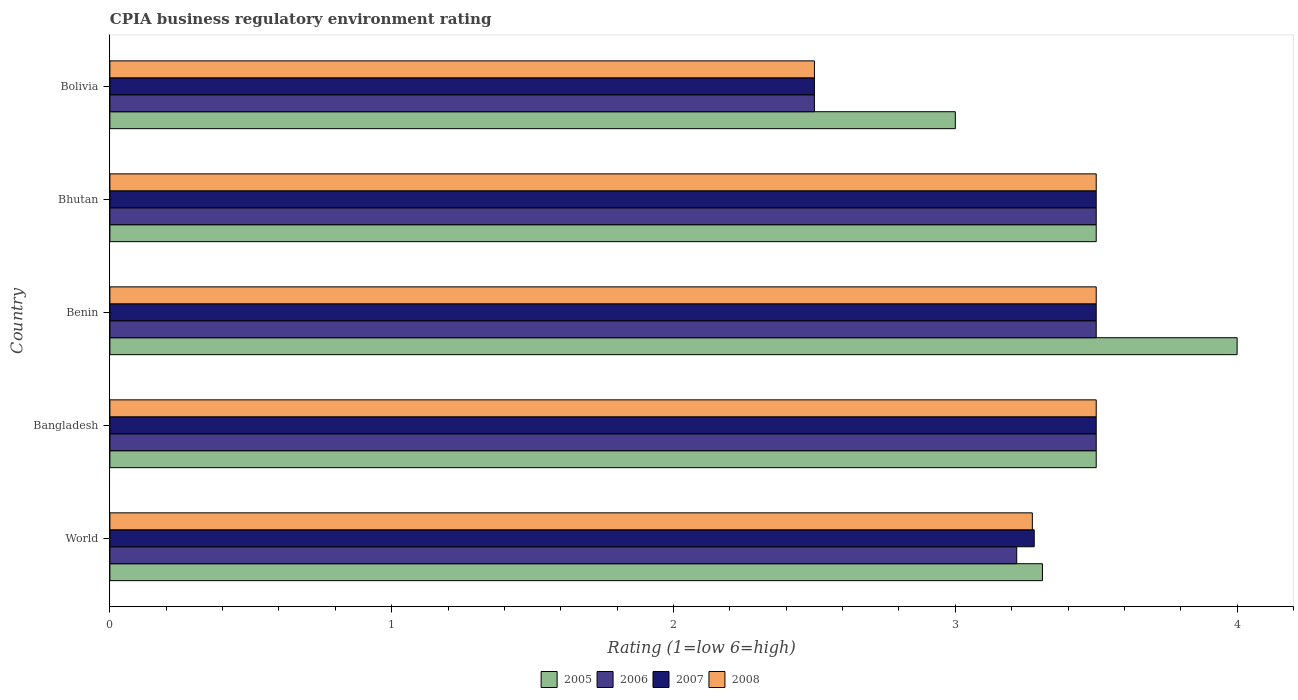How many different coloured bars are there?
Provide a short and direct response. 4. Are the number of bars on each tick of the Y-axis equal?
Offer a terse response. Yes. How many bars are there on the 4th tick from the top?
Offer a terse response. 4. What is the label of the 4th group of bars from the top?
Provide a succinct answer. Bangladesh. In how many cases, is the number of bars for a given country not equal to the number of legend labels?
Ensure brevity in your answer.  0. Across all countries, what is the maximum CPIA rating in 2008?
Ensure brevity in your answer.  3.5. Across all countries, what is the minimum CPIA rating in 2007?
Give a very brief answer. 2.5. What is the total CPIA rating in 2008 in the graph?
Keep it short and to the point. 16.27. What is the difference between the CPIA rating in 2006 in Bolivia and that in World?
Offer a terse response. -0.72. What is the difference between the CPIA rating in 2005 in Bolivia and the CPIA rating in 2007 in Bhutan?
Provide a succinct answer. -0.5. What is the average CPIA rating in 2007 per country?
Your answer should be very brief. 3.26. What is the ratio of the CPIA rating in 2007 in Bolivia to that in World?
Provide a succinct answer. 0.76. Is the CPIA rating in 2005 in Benin less than that in World?
Your response must be concise. No. Is the difference between the CPIA rating in 2005 in Bangladesh and Bolivia greater than the difference between the CPIA rating in 2008 in Bangladesh and Bolivia?
Keep it short and to the point. No. What is the difference between the highest and the second highest CPIA rating in 2005?
Ensure brevity in your answer.  0.5. Is it the case that in every country, the sum of the CPIA rating in 2005 and CPIA rating in 2007 is greater than the sum of CPIA rating in 2006 and CPIA rating in 2008?
Ensure brevity in your answer.  No. What does the 4th bar from the top in Bangladesh represents?
Provide a short and direct response. 2005. What does the 1st bar from the bottom in Benin represents?
Give a very brief answer. 2005. Is it the case that in every country, the sum of the CPIA rating in 2007 and CPIA rating in 2008 is greater than the CPIA rating in 2005?
Provide a short and direct response. Yes. Are all the bars in the graph horizontal?
Give a very brief answer. Yes. How many countries are there in the graph?
Offer a terse response. 5. What is the difference between two consecutive major ticks on the X-axis?
Your answer should be compact. 1. Does the graph contain grids?
Your answer should be very brief. No. How many legend labels are there?
Your answer should be very brief. 4. How are the legend labels stacked?
Offer a terse response. Horizontal. What is the title of the graph?
Provide a short and direct response. CPIA business regulatory environment rating. Does "1987" appear as one of the legend labels in the graph?
Offer a terse response. No. What is the label or title of the Y-axis?
Your answer should be compact. Country. What is the Rating (1=low 6=high) of 2005 in World?
Your answer should be compact. 3.31. What is the Rating (1=low 6=high) of 2006 in World?
Make the answer very short. 3.22. What is the Rating (1=low 6=high) of 2007 in World?
Ensure brevity in your answer.  3.28. What is the Rating (1=low 6=high) in 2008 in World?
Your response must be concise. 3.27. What is the Rating (1=low 6=high) in 2005 in Bangladesh?
Your response must be concise. 3.5. What is the Rating (1=low 6=high) of 2006 in Bangladesh?
Provide a short and direct response. 3.5. What is the Rating (1=low 6=high) of 2007 in Bangladesh?
Give a very brief answer. 3.5. What is the Rating (1=low 6=high) of 2008 in Bangladesh?
Provide a short and direct response. 3.5. What is the Rating (1=low 6=high) of 2005 in Benin?
Give a very brief answer. 4. What is the Rating (1=low 6=high) of 2008 in Bhutan?
Give a very brief answer. 3.5. What is the Rating (1=low 6=high) in 2005 in Bolivia?
Provide a short and direct response. 3. What is the Rating (1=low 6=high) of 2007 in Bolivia?
Your response must be concise. 2.5. What is the Rating (1=low 6=high) of 2008 in Bolivia?
Keep it short and to the point. 2.5. Across all countries, what is the maximum Rating (1=low 6=high) in 2008?
Provide a succinct answer. 3.5. Across all countries, what is the minimum Rating (1=low 6=high) in 2006?
Keep it short and to the point. 2.5. Across all countries, what is the minimum Rating (1=low 6=high) of 2008?
Offer a very short reply. 2.5. What is the total Rating (1=low 6=high) of 2005 in the graph?
Offer a very short reply. 17.31. What is the total Rating (1=low 6=high) of 2006 in the graph?
Your answer should be compact. 16.22. What is the total Rating (1=low 6=high) in 2007 in the graph?
Provide a succinct answer. 16.28. What is the total Rating (1=low 6=high) of 2008 in the graph?
Provide a short and direct response. 16.27. What is the difference between the Rating (1=low 6=high) of 2005 in World and that in Bangladesh?
Offer a terse response. -0.19. What is the difference between the Rating (1=low 6=high) in 2006 in World and that in Bangladesh?
Keep it short and to the point. -0.28. What is the difference between the Rating (1=low 6=high) of 2007 in World and that in Bangladesh?
Give a very brief answer. -0.22. What is the difference between the Rating (1=low 6=high) of 2008 in World and that in Bangladesh?
Provide a short and direct response. -0.23. What is the difference between the Rating (1=low 6=high) in 2005 in World and that in Benin?
Your answer should be very brief. -0.69. What is the difference between the Rating (1=low 6=high) in 2006 in World and that in Benin?
Your answer should be compact. -0.28. What is the difference between the Rating (1=low 6=high) of 2007 in World and that in Benin?
Provide a succinct answer. -0.22. What is the difference between the Rating (1=low 6=high) of 2008 in World and that in Benin?
Your answer should be compact. -0.23. What is the difference between the Rating (1=low 6=high) in 2005 in World and that in Bhutan?
Offer a terse response. -0.19. What is the difference between the Rating (1=low 6=high) in 2006 in World and that in Bhutan?
Offer a terse response. -0.28. What is the difference between the Rating (1=low 6=high) in 2007 in World and that in Bhutan?
Ensure brevity in your answer.  -0.22. What is the difference between the Rating (1=low 6=high) in 2008 in World and that in Bhutan?
Your answer should be compact. -0.23. What is the difference between the Rating (1=low 6=high) in 2005 in World and that in Bolivia?
Give a very brief answer. 0.31. What is the difference between the Rating (1=low 6=high) of 2006 in World and that in Bolivia?
Offer a very short reply. 0.72. What is the difference between the Rating (1=low 6=high) of 2007 in World and that in Bolivia?
Your answer should be compact. 0.78. What is the difference between the Rating (1=low 6=high) in 2008 in World and that in Bolivia?
Give a very brief answer. 0.77. What is the difference between the Rating (1=low 6=high) in 2008 in Bangladesh and that in Benin?
Offer a terse response. 0. What is the difference between the Rating (1=low 6=high) in 2007 in Bangladesh and that in Bhutan?
Your response must be concise. 0. What is the difference between the Rating (1=low 6=high) of 2008 in Bangladesh and that in Bhutan?
Offer a very short reply. 0. What is the difference between the Rating (1=low 6=high) in 2007 in Benin and that in Bhutan?
Make the answer very short. 0. What is the difference between the Rating (1=low 6=high) in 2006 in Benin and that in Bolivia?
Keep it short and to the point. 1. What is the difference between the Rating (1=low 6=high) of 2006 in Bhutan and that in Bolivia?
Offer a terse response. 1. What is the difference between the Rating (1=low 6=high) in 2007 in Bhutan and that in Bolivia?
Your answer should be very brief. 1. What is the difference between the Rating (1=low 6=high) in 2005 in World and the Rating (1=low 6=high) in 2006 in Bangladesh?
Your answer should be very brief. -0.19. What is the difference between the Rating (1=low 6=high) in 2005 in World and the Rating (1=low 6=high) in 2007 in Bangladesh?
Your answer should be compact. -0.19. What is the difference between the Rating (1=low 6=high) in 2005 in World and the Rating (1=low 6=high) in 2008 in Bangladesh?
Provide a short and direct response. -0.19. What is the difference between the Rating (1=low 6=high) in 2006 in World and the Rating (1=low 6=high) in 2007 in Bangladesh?
Your response must be concise. -0.28. What is the difference between the Rating (1=low 6=high) of 2006 in World and the Rating (1=low 6=high) of 2008 in Bangladesh?
Your answer should be compact. -0.28. What is the difference between the Rating (1=low 6=high) in 2007 in World and the Rating (1=low 6=high) in 2008 in Bangladesh?
Provide a succinct answer. -0.22. What is the difference between the Rating (1=low 6=high) in 2005 in World and the Rating (1=low 6=high) in 2006 in Benin?
Keep it short and to the point. -0.19. What is the difference between the Rating (1=low 6=high) of 2005 in World and the Rating (1=low 6=high) of 2007 in Benin?
Your answer should be very brief. -0.19. What is the difference between the Rating (1=low 6=high) in 2005 in World and the Rating (1=low 6=high) in 2008 in Benin?
Ensure brevity in your answer.  -0.19. What is the difference between the Rating (1=low 6=high) in 2006 in World and the Rating (1=low 6=high) in 2007 in Benin?
Your answer should be very brief. -0.28. What is the difference between the Rating (1=low 6=high) in 2006 in World and the Rating (1=low 6=high) in 2008 in Benin?
Your answer should be compact. -0.28. What is the difference between the Rating (1=low 6=high) of 2007 in World and the Rating (1=low 6=high) of 2008 in Benin?
Provide a succinct answer. -0.22. What is the difference between the Rating (1=low 6=high) of 2005 in World and the Rating (1=low 6=high) of 2006 in Bhutan?
Make the answer very short. -0.19. What is the difference between the Rating (1=low 6=high) of 2005 in World and the Rating (1=low 6=high) of 2007 in Bhutan?
Keep it short and to the point. -0.19. What is the difference between the Rating (1=low 6=high) of 2005 in World and the Rating (1=low 6=high) of 2008 in Bhutan?
Give a very brief answer. -0.19. What is the difference between the Rating (1=low 6=high) in 2006 in World and the Rating (1=low 6=high) in 2007 in Bhutan?
Provide a succinct answer. -0.28. What is the difference between the Rating (1=low 6=high) of 2006 in World and the Rating (1=low 6=high) of 2008 in Bhutan?
Ensure brevity in your answer.  -0.28. What is the difference between the Rating (1=low 6=high) of 2007 in World and the Rating (1=low 6=high) of 2008 in Bhutan?
Keep it short and to the point. -0.22. What is the difference between the Rating (1=low 6=high) in 2005 in World and the Rating (1=low 6=high) in 2006 in Bolivia?
Provide a succinct answer. 0.81. What is the difference between the Rating (1=low 6=high) of 2005 in World and the Rating (1=low 6=high) of 2007 in Bolivia?
Your answer should be very brief. 0.81. What is the difference between the Rating (1=low 6=high) of 2005 in World and the Rating (1=low 6=high) of 2008 in Bolivia?
Your answer should be very brief. 0.81. What is the difference between the Rating (1=low 6=high) in 2006 in World and the Rating (1=low 6=high) in 2007 in Bolivia?
Your response must be concise. 0.72. What is the difference between the Rating (1=low 6=high) in 2006 in World and the Rating (1=low 6=high) in 2008 in Bolivia?
Ensure brevity in your answer.  0.72. What is the difference between the Rating (1=low 6=high) of 2007 in World and the Rating (1=low 6=high) of 2008 in Bolivia?
Provide a succinct answer. 0.78. What is the difference between the Rating (1=low 6=high) of 2005 in Bangladesh and the Rating (1=low 6=high) of 2006 in Benin?
Provide a short and direct response. 0. What is the difference between the Rating (1=low 6=high) in 2005 in Bangladesh and the Rating (1=low 6=high) in 2007 in Benin?
Offer a terse response. 0. What is the difference between the Rating (1=low 6=high) in 2005 in Bangladesh and the Rating (1=low 6=high) in 2008 in Benin?
Offer a very short reply. 0. What is the difference between the Rating (1=low 6=high) of 2006 in Bangladesh and the Rating (1=low 6=high) of 2007 in Benin?
Give a very brief answer. 0. What is the difference between the Rating (1=low 6=high) in 2006 in Bangladesh and the Rating (1=low 6=high) in 2008 in Benin?
Your answer should be compact. 0. What is the difference between the Rating (1=low 6=high) of 2005 in Bangladesh and the Rating (1=low 6=high) of 2007 in Bhutan?
Offer a terse response. 0. What is the difference between the Rating (1=low 6=high) in 2005 in Bangladesh and the Rating (1=low 6=high) in 2008 in Bhutan?
Your response must be concise. 0. What is the difference between the Rating (1=low 6=high) in 2006 in Bangladesh and the Rating (1=low 6=high) in 2007 in Bhutan?
Make the answer very short. 0. What is the difference between the Rating (1=low 6=high) in 2006 in Bangladesh and the Rating (1=low 6=high) in 2008 in Bhutan?
Ensure brevity in your answer.  0. What is the difference between the Rating (1=low 6=high) of 2005 in Bangladesh and the Rating (1=low 6=high) of 2006 in Bolivia?
Provide a short and direct response. 1. What is the difference between the Rating (1=low 6=high) of 2007 in Bangladesh and the Rating (1=low 6=high) of 2008 in Bolivia?
Give a very brief answer. 1. What is the difference between the Rating (1=low 6=high) of 2005 in Benin and the Rating (1=low 6=high) of 2006 in Bhutan?
Make the answer very short. 0.5. What is the difference between the Rating (1=low 6=high) in 2005 in Benin and the Rating (1=low 6=high) in 2008 in Bhutan?
Your response must be concise. 0.5. What is the difference between the Rating (1=low 6=high) in 2006 in Benin and the Rating (1=low 6=high) in 2007 in Bhutan?
Give a very brief answer. 0. What is the difference between the Rating (1=low 6=high) in 2006 in Benin and the Rating (1=low 6=high) in 2008 in Bhutan?
Your answer should be very brief. 0. What is the difference between the Rating (1=low 6=high) of 2007 in Benin and the Rating (1=low 6=high) of 2008 in Bhutan?
Provide a short and direct response. 0. What is the difference between the Rating (1=low 6=high) in 2005 in Benin and the Rating (1=low 6=high) in 2007 in Bolivia?
Your response must be concise. 1.5. What is the difference between the Rating (1=low 6=high) in 2006 in Benin and the Rating (1=low 6=high) in 2007 in Bolivia?
Ensure brevity in your answer.  1. What is the difference between the Rating (1=low 6=high) in 2005 in Bhutan and the Rating (1=low 6=high) in 2006 in Bolivia?
Offer a terse response. 1. What is the difference between the Rating (1=low 6=high) in 2005 in Bhutan and the Rating (1=low 6=high) in 2007 in Bolivia?
Offer a very short reply. 1. What is the difference between the Rating (1=low 6=high) of 2006 in Bhutan and the Rating (1=low 6=high) of 2007 in Bolivia?
Offer a very short reply. 1. What is the difference between the Rating (1=low 6=high) in 2006 in Bhutan and the Rating (1=low 6=high) in 2008 in Bolivia?
Offer a terse response. 1. What is the average Rating (1=low 6=high) in 2005 per country?
Keep it short and to the point. 3.46. What is the average Rating (1=low 6=high) in 2006 per country?
Your answer should be very brief. 3.24. What is the average Rating (1=low 6=high) in 2007 per country?
Offer a terse response. 3.26. What is the average Rating (1=low 6=high) of 2008 per country?
Ensure brevity in your answer.  3.25. What is the difference between the Rating (1=low 6=high) in 2005 and Rating (1=low 6=high) in 2006 in World?
Give a very brief answer. 0.09. What is the difference between the Rating (1=low 6=high) in 2005 and Rating (1=low 6=high) in 2007 in World?
Your answer should be very brief. 0.03. What is the difference between the Rating (1=low 6=high) in 2005 and Rating (1=low 6=high) in 2008 in World?
Your answer should be compact. 0.04. What is the difference between the Rating (1=low 6=high) of 2006 and Rating (1=low 6=high) of 2007 in World?
Offer a terse response. -0.06. What is the difference between the Rating (1=low 6=high) in 2006 and Rating (1=low 6=high) in 2008 in World?
Give a very brief answer. -0.06. What is the difference between the Rating (1=low 6=high) of 2007 and Rating (1=low 6=high) of 2008 in World?
Your answer should be compact. 0.01. What is the difference between the Rating (1=low 6=high) in 2005 and Rating (1=low 6=high) in 2007 in Bangladesh?
Make the answer very short. 0. What is the difference between the Rating (1=low 6=high) of 2006 and Rating (1=low 6=high) of 2008 in Bangladesh?
Your answer should be very brief. 0. What is the difference between the Rating (1=low 6=high) in 2005 and Rating (1=low 6=high) in 2007 in Benin?
Provide a succinct answer. 0.5. What is the difference between the Rating (1=low 6=high) in 2005 and Rating (1=low 6=high) in 2008 in Benin?
Your response must be concise. 0.5. What is the difference between the Rating (1=low 6=high) of 2006 and Rating (1=low 6=high) of 2007 in Benin?
Provide a succinct answer. 0. What is the difference between the Rating (1=low 6=high) of 2006 and Rating (1=low 6=high) of 2008 in Benin?
Give a very brief answer. 0. What is the difference between the Rating (1=low 6=high) in 2007 and Rating (1=low 6=high) in 2008 in Benin?
Your answer should be compact. 0. What is the difference between the Rating (1=low 6=high) of 2006 and Rating (1=low 6=high) of 2007 in Bhutan?
Give a very brief answer. 0. What is the difference between the Rating (1=low 6=high) in 2006 and Rating (1=low 6=high) in 2008 in Bhutan?
Offer a terse response. 0. What is the difference between the Rating (1=low 6=high) of 2007 and Rating (1=low 6=high) of 2008 in Bhutan?
Your response must be concise. 0. What is the difference between the Rating (1=low 6=high) of 2005 and Rating (1=low 6=high) of 2006 in Bolivia?
Make the answer very short. 0.5. What is the difference between the Rating (1=low 6=high) in 2006 and Rating (1=low 6=high) in 2007 in Bolivia?
Provide a succinct answer. 0. What is the difference between the Rating (1=low 6=high) of 2007 and Rating (1=low 6=high) of 2008 in Bolivia?
Offer a terse response. 0. What is the ratio of the Rating (1=low 6=high) in 2005 in World to that in Bangladesh?
Your response must be concise. 0.95. What is the ratio of the Rating (1=low 6=high) of 2006 in World to that in Bangladesh?
Keep it short and to the point. 0.92. What is the ratio of the Rating (1=low 6=high) of 2007 in World to that in Bangladesh?
Provide a short and direct response. 0.94. What is the ratio of the Rating (1=low 6=high) of 2008 in World to that in Bangladesh?
Your response must be concise. 0.94. What is the ratio of the Rating (1=low 6=high) of 2005 in World to that in Benin?
Make the answer very short. 0.83. What is the ratio of the Rating (1=low 6=high) in 2006 in World to that in Benin?
Provide a short and direct response. 0.92. What is the ratio of the Rating (1=low 6=high) in 2007 in World to that in Benin?
Ensure brevity in your answer.  0.94. What is the ratio of the Rating (1=low 6=high) of 2008 in World to that in Benin?
Your answer should be compact. 0.94. What is the ratio of the Rating (1=low 6=high) of 2005 in World to that in Bhutan?
Ensure brevity in your answer.  0.95. What is the ratio of the Rating (1=low 6=high) in 2006 in World to that in Bhutan?
Give a very brief answer. 0.92. What is the ratio of the Rating (1=low 6=high) of 2007 in World to that in Bhutan?
Make the answer very short. 0.94. What is the ratio of the Rating (1=low 6=high) of 2008 in World to that in Bhutan?
Your response must be concise. 0.94. What is the ratio of the Rating (1=low 6=high) of 2005 in World to that in Bolivia?
Your answer should be compact. 1.1. What is the ratio of the Rating (1=low 6=high) in 2006 in World to that in Bolivia?
Provide a succinct answer. 1.29. What is the ratio of the Rating (1=low 6=high) of 2007 in World to that in Bolivia?
Your response must be concise. 1.31. What is the ratio of the Rating (1=low 6=high) in 2008 in World to that in Bolivia?
Your response must be concise. 1.31. What is the ratio of the Rating (1=low 6=high) in 2005 in Bangladesh to that in Benin?
Offer a very short reply. 0.88. What is the ratio of the Rating (1=low 6=high) in 2007 in Bangladesh to that in Benin?
Make the answer very short. 1. What is the ratio of the Rating (1=low 6=high) in 2008 in Bangladesh to that in Benin?
Offer a very short reply. 1. What is the ratio of the Rating (1=low 6=high) in 2005 in Bangladesh to that in Bhutan?
Give a very brief answer. 1. What is the ratio of the Rating (1=low 6=high) in 2006 in Bangladesh to that in Bhutan?
Ensure brevity in your answer.  1. What is the ratio of the Rating (1=low 6=high) of 2008 in Bangladesh to that in Bhutan?
Your answer should be compact. 1. What is the ratio of the Rating (1=low 6=high) in 2007 in Bangladesh to that in Bolivia?
Provide a short and direct response. 1.4. What is the ratio of the Rating (1=low 6=high) in 2006 in Benin to that in Bhutan?
Your answer should be compact. 1. What is the ratio of the Rating (1=low 6=high) of 2008 in Benin to that in Bhutan?
Provide a short and direct response. 1. What is the ratio of the Rating (1=low 6=high) in 2005 in Benin to that in Bolivia?
Your answer should be very brief. 1.33. What is the ratio of the Rating (1=low 6=high) of 2006 in Benin to that in Bolivia?
Your response must be concise. 1.4. What is the ratio of the Rating (1=low 6=high) in 2008 in Benin to that in Bolivia?
Ensure brevity in your answer.  1.4. What is the ratio of the Rating (1=low 6=high) in 2005 in Bhutan to that in Bolivia?
Your answer should be very brief. 1.17. What is the difference between the highest and the second highest Rating (1=low 6=high) of 2005?
Offer a very short reply. 0.5. What is the difference between the highest and the second highest Rating (1=low 6=high) of 2006?
Your response must be concise. 0. What is the difference between the highest and the second highest Rating (1=low 6=high) of 2007?
Keep it short and to the point. 0. What is the difference between the highest and the second highest Rating (1=low 6=high) in 2008?
Your response must be concise. 0. What is the difference between the highest and the lowest Rating (1=low 6=high) of 2006?
Provide a succinct answer. 1. What is the difference between the highest and the lowest Rating (1=low 6=high) of 2007?
Offer a terse response. 1. What is the difference between the highest and the lowest Rating (1=low 6=high) in 2008?
Keep it short and to the point. 1. 